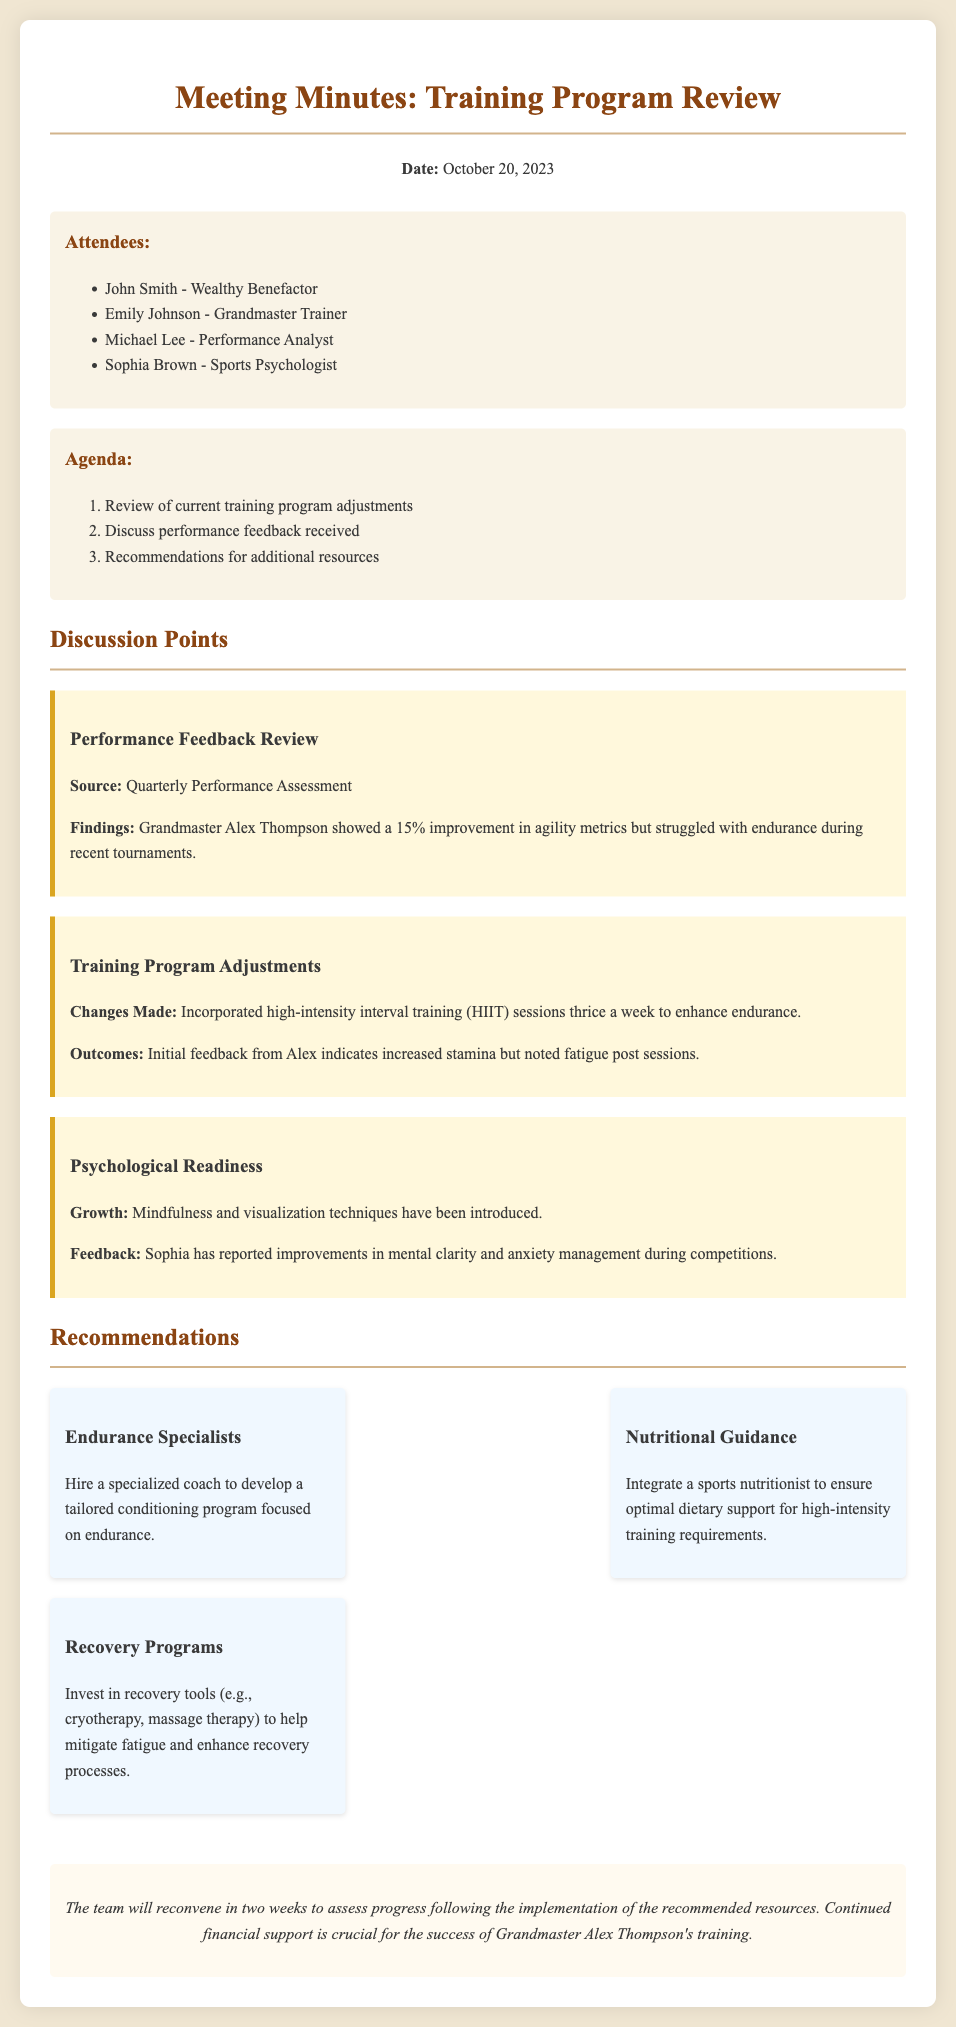What is the date of the meeting? The date of the meeting is explicitly mentioned in the document's header.
Answer: October 20, 2023 Who showed a 15% improvement in agility metrics? The performance feedback review section states who improved in agility metrics.
Answer: Grandmaster Alex Thompson What training technique was incorporated thrice a week? The discussion about training program adjustments mentions this specific training technique.
Answer: High-intensity interval training (HIIT) What role does Sophia Brown have? Her role is listed alongside other attendees in the document.
Answer: Sports Psychologist What should be integrated for optimal dietary support? The recommendations section details the additional resources needed for training.
Answer: Sports nutritionist Why did Alex Thompson report fatigue post sessions? This is noted in the outcomes of the training adjustments made.
Answer: Increased stamina What is the focus of the specialized coach to be hired? This is specified in the recommendations concerning new hires for training improvement.
Answer: Endurance How often will the team reconvene to assess progress? The conclusion specifies the frequency of future meetings.
Answer: In two weeks 